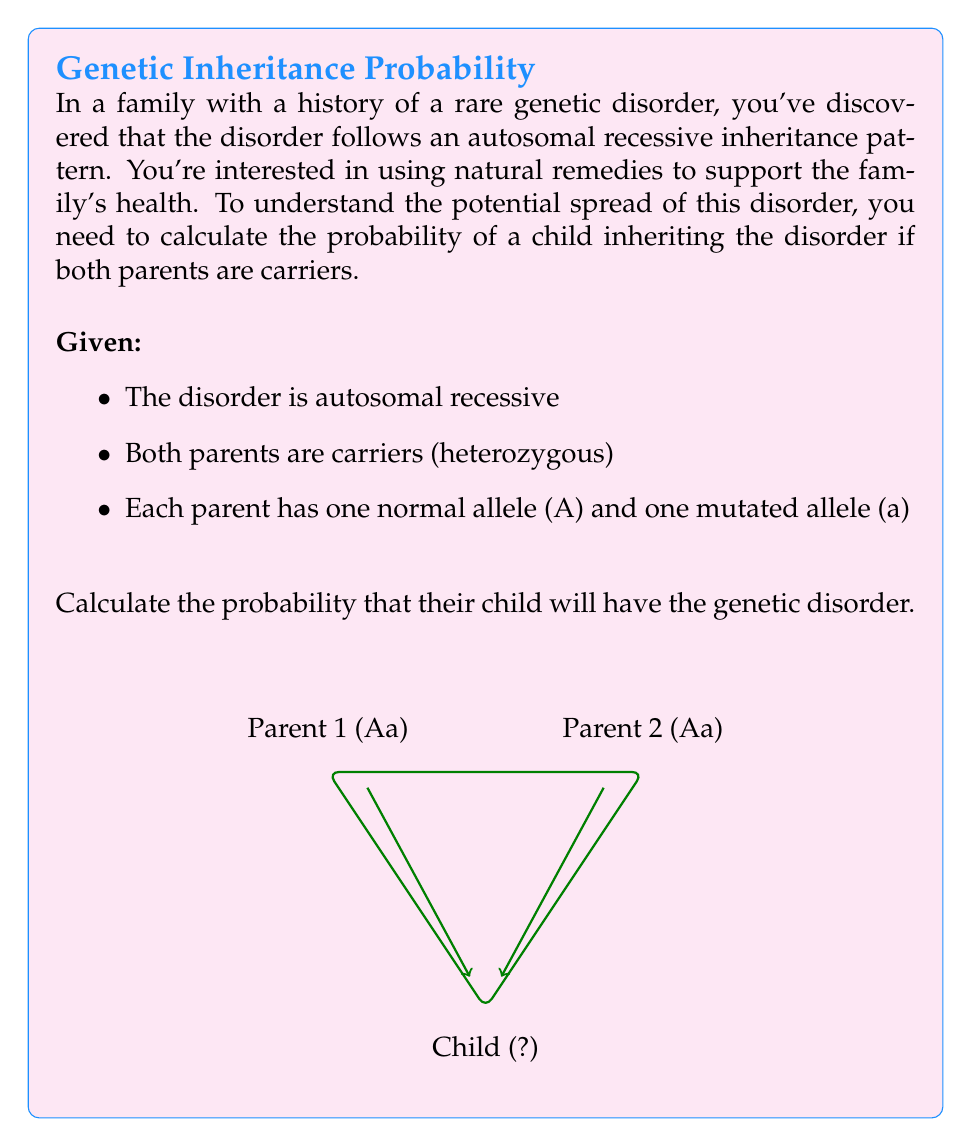Can you answer this question? To solve this problem, we'll use probability theory and Punnett squares, a fundamental tool in genetics.

Step 1: Identify the genotypes of the parents
Both parents are carriers, so their genotypes are Aa (heterozygous).

Step 2: Create a Punnett square
$$
\begin{array}{c|cc}
 & A & a \\
\hline
A & AA & Aa \\
a & Aa & aa \\
\end{array}
$$

Step 3: Analyze the possible outcomes
- AA: Normal (homozygous dominant)
- Aa: Carrier (heterozygous)
- aa: Affected (homozygous recessive)

Step 4: Calculate the probability of each outcome
- P(AA) = 1/4
- P(Aa) = 1/2
- P(aa) = 1/4

Step 5: Identify the probability of inheriting the disorder
The child will have the disorder only if they inherit the 'a' allele from both parents, resulting in the 'aa' genotype.

P(child has the disorder) = P(aa) = 1/4 = 0.25 = 25%

Therefore, there is a 25% chance that the child will inherit the genetic disorder.
Answer: 0.25 or 25% 